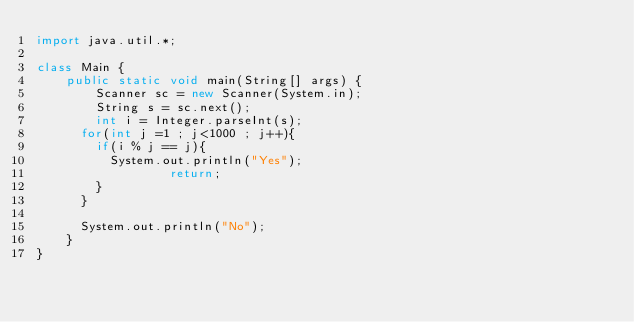<code> <loc_0><loc_0><loc_500><loc_500><_Java_>import java.util.*;

class Main {
    public static void main(String[] args) {
        Scanner sc = new Scanner(System.in);
        String s = sc.next();
        int i = Integer.parseInt(s);
      for(int j =1 ; j<1000 ; j++){
        if(i % j == j){
          System.out.println("Yes");
        	      return;
        }
      }

      System.out.println("No");
    }
}</code> 